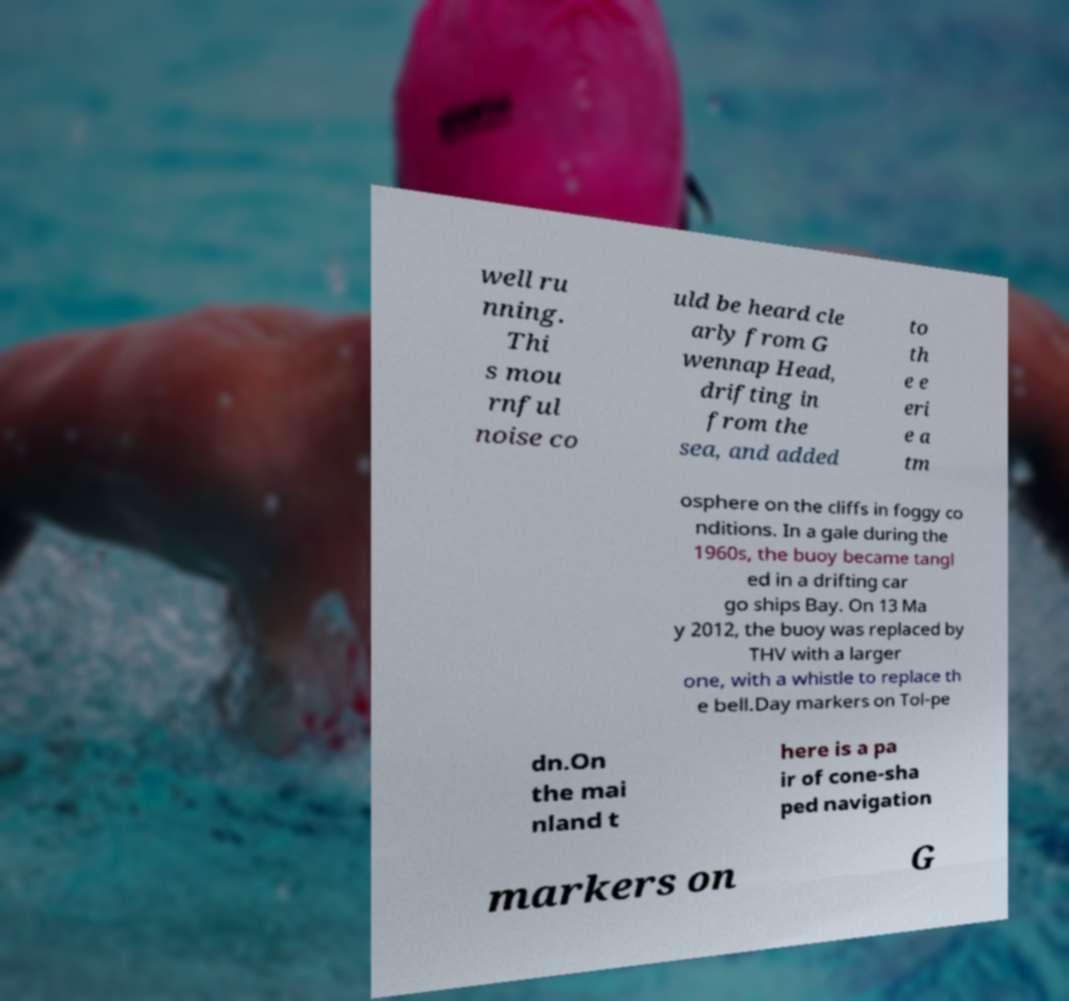Could you extract and type out the text from this image? well ru nning. Thi s mou rnful noise co uld be heard cle arly from G wennap Head, drifting in from the sea, and added to th e e eri e a tm osphere on the cliffs in foggy co nditions. In a gale during the 1960s, the buoy became tangl ed in a drifting car go ships Bay. On 13 Ma y 2012, the buoy was replaced by THV with a larger one, with a whistle to replace th e bell.Day markers on Tol-pe dn.On the mai nland t here is a pa ir of cone-sha ped navigation markers on G 